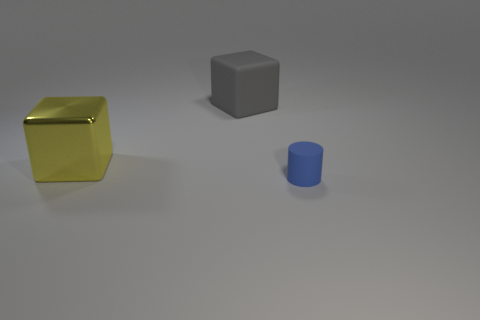What materials do the objects seem to be made of? The objects appear to be made of different materials. The cube on the left has a reflective surface that suggests it's metallic, likely simulating a material like gold. The middle object, a cube as well, exhibits a matte finish that might indicate a plastic or painted wood material. Lastly, the cylinder on the right appears to have a surface texture consistent with plastic or painted metal. 